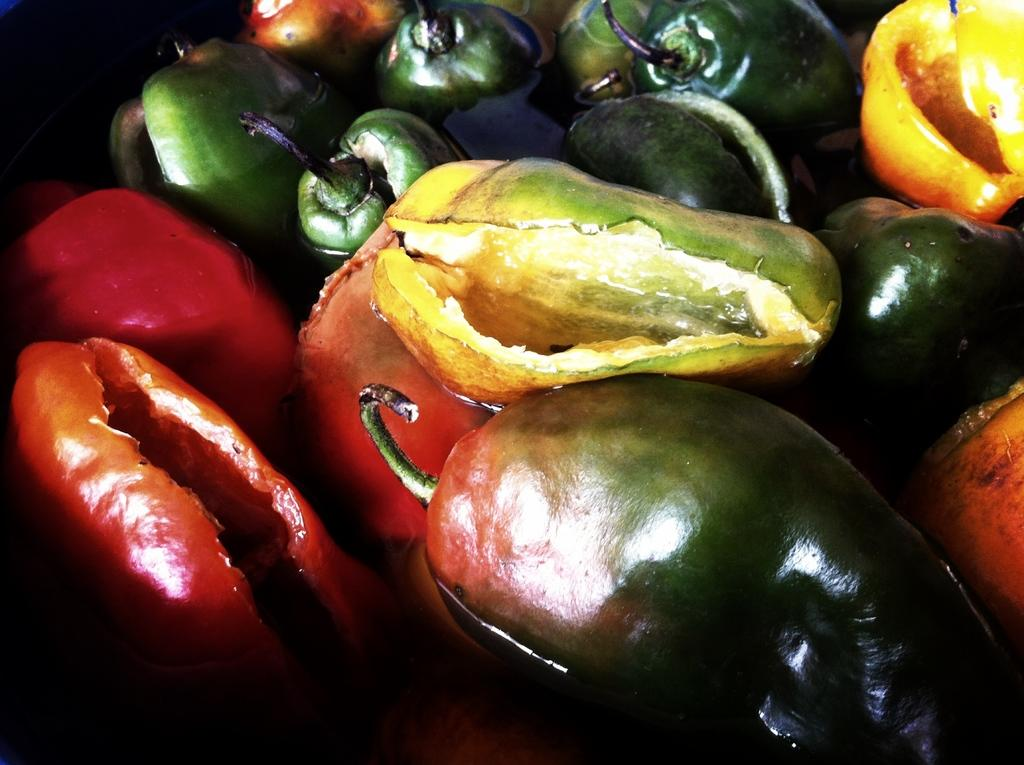What type of chilies can be seen in the image? There are green chilies and red chilies in the image. What is the condition of the chilies in the image? The chilies are soaked in water. What letters are written on the chilies in the image? There are no letters written on the chilies in the image. How many dogs can be seen playing with the chilies in the image? There are no dogs present in the image. 